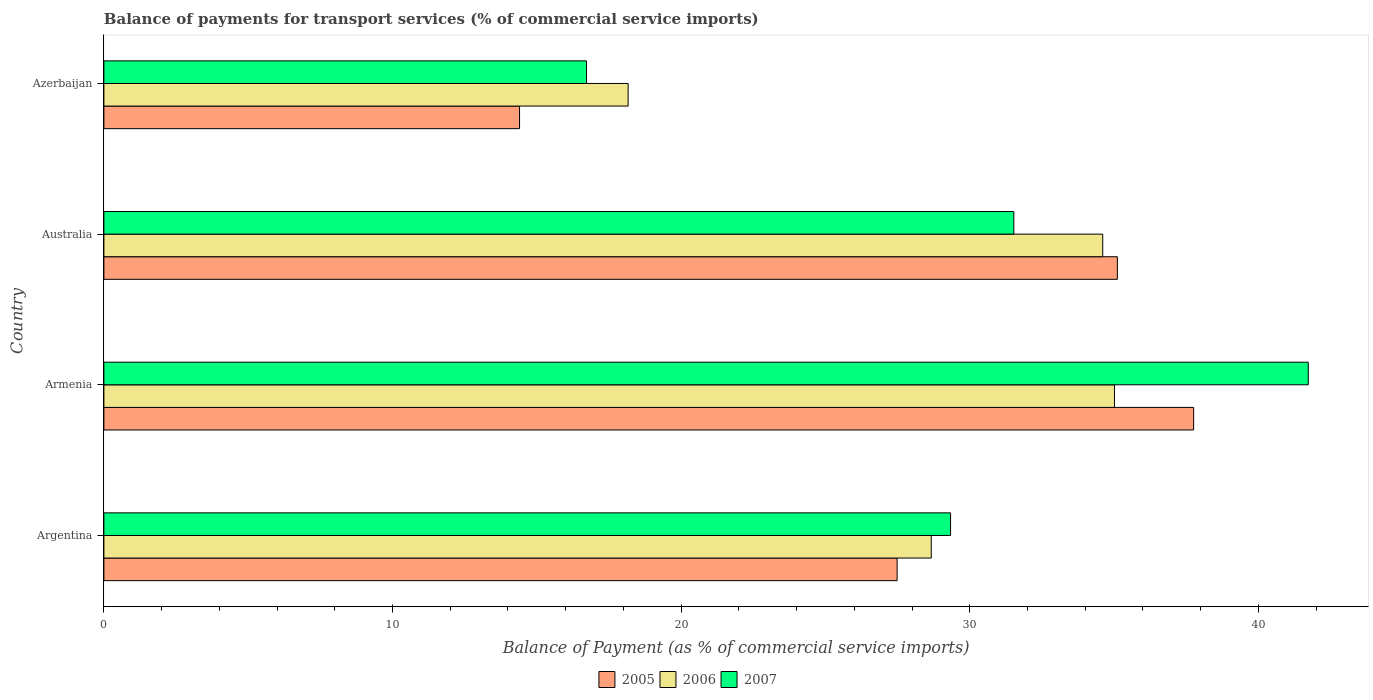How many different coloured bars are there?
Provide a short and direct response. 3. How many groups of bars are there?
Provide a succinct answer. 4. Are the number of bars per tick equal to the number of legend labels?
Give a very brief answer. Yes. How many bars are there on the 2nd tick from the top?
Offer a very short reply. 3. In how many cases, is the number of bars for a given country not equal to the number of legend labels?
Your answer should be compact. 0. What is the balance of payments for transport services in 2007 in Australia?
Your answer should be compact. 31.53. Across all countries, what is the maximum balance of payments for transport services in 2006?
Keep it short and to the point. 35.01. Across all countries, what is the minimum balance of payments for transport services in 2005?
Your response must be concise. 14.4. In which country was the balance of payments for transport services in 2005 maximum?
Provide a short and direct response. Armenia. In which country was the balance of payments for transport services in 2005 minimum?
Keep it short and to the point. Azerbaijan. What is the total balance of payments for transport services in 2007 in the graph?
Provide a succinct answer. 119.31. What is the difference between the balance of payments for transport services in 2007 in Argentina and that in Azerbaijan?
Offer a very short reply. 12.61. What is the difference between the balance of payments for transport services in 2005 in Argentina and the balance of payments for transport services in 2007 in Armenia?
Provide a short and direct response. -14.25. What is the average balance of payments for transport services in 2006 per country?
Give a very brief answer. 29.11. What is the difference between the balance of payments for transport services in 2006 and balance of payments for transport services in 2007 in Australia?
Provide a short and direct response. 3.08. In how many countries, is the balance of payments for transport services in 2006 greater than 26 %?
Ensure brevity in your answer.  3. What is the ratio of the balance of payments for transport services in 2006 in Armenia to that in Azerbaijan?
Your response must be concise. 1.93. Is the balance of payments for transport services in 2007 in Australia less than that in Azerbaijan?
Your answer should be compact. No. Is the difference between the balance of payments for transport services in 2006 in Argentina and Australia greater than the difference between the balance of payments for transport services in 2007 in Argentina and Australia?
Offer a very short reply. No. What is the difference between the highest and the second highest balance of payments for transport services in 2005?
Ensure brevity in your answer.  2.64. What is the difference between the highest and the lowest balance of payments for transport services in 2005?
Your response must be concise. 23.36. In how many countries, is the balance of payments for transport services in 2007 greater than the average balance of payments for transport services in 2007 taken over all countries?
Offer a very short reply. 2. Is it the case that in every country, the sum of the balance of payments for transport services in 2007 and balance of payments for transport services in 2006 is greater than the balance of payments for transport services in 2005?
Your answer should be compact. Yes. What is the difference between two consecutive major ticks on the X-axis?
Your answer should be compact. 10. Are the values on the major ticks of X-axis written in scientific E-notation?
Ensure brevity in your answer.  No. Does the graph contain any zero values?
Keep it short and to the point. No. How many legend labels are there?
Ensure brevity in your answer.  3. How are the legend labels stacked?
Provide a succinct answer. Horizontal. What is the title of the graph?
Ensure brevity in your answer.  Balance of payments for transport services (% of commercial service imports). Does "1976" appear as one of the legend labels in the graph?
Offer a terse response. No. What is the label or title of the X-axis?
Ensure brevity in your answer.  Balance of Payment (as % of commercial service imports). What is the Balance of Payment (as % of commercial service imports) in 2005 in Argentina?
Offer a very short reply. 27.48. What is the Balance of Payment (as % of commercial service imports) in 2006 in Argentina?
Offer a very short reply. 28.67. What is the Balance of Payment (as % of commercial service imports) of 2007 in Argentina?
Make the answer very short. 29.34. What is the Balance of Payment (as % of commercial service imports) in 2005 in Armenia?
Offer a terse response. 37.76. What is the Balance of Payment (as % of commercial service imports) in 2006 in Armenia?
Offer a very short reply. 35.01. What is the Balance of Payment (as % of commercial service imports) in 2007 in Armenia?
Give a very brief answer. 41.73. What is the Balance of Payment (as % of commercial service imports) in 2005 in Australia?
Your answer should be compact. 35.11. What is the Balance of Payment (as % of commercial service imports) in 2006 in Australia?
Offer a very short reply. 34.61. What is the Balance of Payment (as % of commercial service imports) in 2007 in Australia?
Provide a succinct answer. 31.53. What is the Balance of Payment (as % of commercial service imports) in 2005 in Azerbaijan?
Make the answer very short. 14.4. What is the Balance of Payment (as % of commercial service imports) in 2006 in Azerbaijan?
Provide a short and direct response. 18.16. What is the Balance of Payment (as % of commercial service imports) in 2007 in Azerbaijan?
Provide a succinct answer. 16.72. Across all countries, what is the maximum Balance of Payment (as % of commercial service imports) of 2005?
Make the answer very short. 37.76. Across all countries, what is the maximum Balance of Payment (as % of commercial service imports) in 2006?
Provide a short and direct response. 35.01. Across all countries, what is the maximum Balance of Payment (as % of commercial service imports) in 2007?
Offer a very short reply. 41.73. Across all countries, what is the minimum Balance of Payment (as % of commercial service imports) of 2005?
Offer a very short reply. 14.4. Across all countries, what is the minimum Balance of Payment (as % of commercial service imports) in 2006?
Provide a short and direct response. 18.16. Across all countries, what is the minimum Balance of Payment (as % of commercial service imports) of 2007?
Your answer should be compact. 16.72. What is the total Balance of Payment (as % of commercial service imports) of 2005 in the graph?
Make the answer very short. 114.76. What is the total Balance of Payment (as % of commercial service imports) in 2006 in the graph?
Your response must be concise. 116.45. What is the total Balance of Payment (as % of commercial service imports) of 2007 in the graph?
Your response must be concise. 119.31. What is the difference between the Balance of Payment (as % of commercial service imports) in 2005 in Argentina and that in Armenia?
Provide a succinct answer. -10.27. What is the difference between the Balance of Payment (as % of commercial service imports) of 2006 in Argentina and that in Armenia?
Provide a short and direct response. -6.35. What is the difference between the Balance of Payment (as % of commercial service imports) in 2007 in Argentina and that in Armenia?
Provide a short and direct response. -12.39. What is the difference between the Balance of Payment (as % of commercial service imports) of 2005 in Argentina and that in Australia?
Ensure brevity in your answer.  -7.63. What is the difference between the Balance of Payment (as % of commercial service imports) of 2006 in Argentina and that in Australia?
Your answer should be compact. -5.94. What is the difference between the Balance of Payment (as % of commercial service imports) in 2007 in Argentina and that in Australia?
Your answer should be compact. -2.19. What is the difference between the Balance of Payment (as % of commercial service imports) of 2005 in Argentina and that in Azerbaijan?
Make the answer very short. 13.08. What is the difference between the Balance of Payment (as % of commercial service imports) in 2006 in Argentina and that in Azerbaijan?
Your answer should be very brief. 10.5. What is the difference between the Balance of Payment (as % of commercial service imports) of 2007 in Argentina and that in Azerbaijan?
Provide a short and direct response. 12.61. What is the difference between the Balance of Payment (as % of commercial service imports) in 2005 in Armenia and that in Australia?
Your answer should be very brief. 2.64. What is the difference between the Balance of Payment (as % of commercial service imports) in 2006 in Armenia and that in Australia?
Your answer should be compact. 0.41. What is the difference between the Balance of Payment (as % of commercial service imports) in 2007 in Armenia and that in Australia?
Your response must be concise. 10.2. What is the difference between the Balance of Payment (as % of commercial service imports) in 2005 in Armenia and that in Azerbaijan?
Make the answer very short. 23.36. What is the difference between the Balance of Payment (as % of commercial service imports) in 2006 in Armenia and that in Azerbaijan?
Offer a very short reply. 16.85. What is the difference between the Balance of Payment (as % of commercial service imports) in 2007 in Armenia and that in Azerbaijan?
Ensure brevity in your answer.  25.01. What is the difference between the Balance of Payment (as % of commercial service imports) in 2005 in Australia and that in Azerbaijan?
Your response must be concise. 20.71. What is the difference between the Balance of Payment (as % of commercial service imports) in 2006 in Australia and that in Azerbaijan?
Give a very brief answer. 16.44. What is the difference between the Balance of Payment (as % of commercial service imports) in 2007 in Australia and that in Azerbaijan?
Give a very brief answer. 14.81. What is the difference between the Balance of Payment (as % of commercial service imports) of 2005 in Argentina and the Balance of Payment (as % of commercial service imports) of 2006 in Armenia?
Give a very brief answer. -7.53. What is the difference between the Balance of Payment (as % of commercial service imports) of 2005 in Argentina and the Balance of Payment (as % of commercial service imports) of 2007 in Armenia?
Your answer should be very brief. -14.25. What is the difference between the Balance of Payment (as % of commercial service imports) of 2006 in Argentina and the Balance of Payment (as % of commercial service imports) of 2007 in Armenia?
Your response must be concise. -13.06. What is the difference between the Balance of Payment (as % of commercial service imports) of 2005 in Argentina and the Balance of Payment (as % of commercial service imports) of 2006 in Australia?
Keep it short and to the point. -7.12. What is the difference between the Balance of Payment (as % of commercial service imports) of 2005 in Argentina and the Balance of Payment (as % of commercial service imports) of 2007 in Australia?
Give a very brief answer. -4.04. What is the difference between the Balance of Payment (as % of commercial service imports) in 2006 in Argentina and the Balance of Payment (as % of commercial service imports) in 2007 in Australia?
Your answer should be very brief. -2.86. What is the difference between the Balance of Payment (as % of commercial service imports) in 2005 in Argentina and the Balance of Payment (as % of commercial service imports) in 2006 in Azerbaijan?
Offer a terse response. 9.32. What is the difference between the Balance of Payment (as % of commercial service imports) in 2005 in Argentina and the Balance of Payment (as % of commercial service imports) in 2007 in Azerbaijan?
Ensure brevity in your answer.  10.76. What is the difference between the Balance of Payment (as % of commercial service imports) in 2006 in Argentina and the Balance of Payment (as % of commercial service imports) in 2007 in Azerbaijan?
Offer a terse response. 11.95. What is the difference between the Balance of Payment (as % of commercial service imports) in 2005 in Armenia and the Balance of Payment (as % of commercial service imports) in 2006 in Australia?
Offer a very short reply. 3.15. What is the difference between the Balance of Payment (as % of commercial service imports) of 2005 in Armenia and the Balance of Payment (as % of commercial service imports) of 2007 in Australia?
Give a very brief answer. 6.23. What is the difference between the Balance of Payment (as % of commercial service imports) of 2006 in Armenia and the Balance of Payment (as % of commercial service imports) of 2007 in Australia?
Provide a succinct answer. 3.49. What is the difference between the Balance of Payment (as % of commercial service imports) of 2005 in Armenia and the Balance of Payment (as % of commercial service imports) of 2006 in Azerbaijan?
Your answer should be very brief. 19.59. What is the difference between the Balance of Payment (as % of commercial service imports) in 2005 in Armenia and the Balance of Payment (as % of commercial service imports) in 2007 in Azerbaijan?
Ensure brevity in your answer.  21.04. What is the difference between the Balance of Payment (as % of commercial service imports) of 2006 in Armenia and the Balance of Payment (as % of commercial service imports) of 2007 in Azerbaijan?
Offer a terse response. 18.29. What is the difference between the Balance of Payment (as % of commercial service imports) of 2005 in Australia and the Balance of Payment (as % of commercial service imports) of 2006 in Azerbaijan?
Your response must be concise. 16.95. What is the difference between the Balance of Payment (as % of commercial service imports) in 2005 in Australia and the Balance of Payment (as % of commercial service imports) in 2007 in Azerbaijan?
Your answer should be compact. 18.39. What is the difference between the Balance of Payment (as % of commercial service imports) in 2006 in Australia and the Balance of Payment (as % of commercial service imports) in 2007 in Azerbaijan?
Make the answer very short. 17.89. What is the average Balance of Payment (as % of commercial service imports) of 2005 per country?
Make the answer very short. 28.69. What is the average Balance of Payment (as % of commercial service imports) in 2006 per country?
Your answer should be very brief. 29.11. What is the average Balance of Payment (as % of commercial service imports) of 2007 per country?
Your answer should be compact. 29.83. What is the difference between the Balance of Payment (as % of commercial service imports) of 2005 and Balance of Payment (as % of commercial service imports) of 2006 in Argentina?
Your response must be concise. -1.18. What is the difference between the Balance of Payment (as % of commercial service imports) of 2005 and Balance of Payment (as % of commercial service imports) of 2007 in Argentina?
Make the answer very short. -1.85. What is the difference between the Balance of Payment (as % of commercial service imports) of 2006 and Balance of Payment (as % of commercial service imports) of 2007 in Argentina?
Give a very brief answer. -0.67. What is the difference between the Balance of Payment (as % of commercial service imports) of 2005 and Balance of Payment (as % of commercial service imports) of 2006 in Armenia?
Offer a terse response. 2.74. What is the difference between the Balance of Payment (as % of commercial service imports) of 2005 and Balance of Payment (as % of commercial service imports) of 2007 in Armenia?
Offer a terse response. -3.97. What is the difference between the Balance of Payment (as % of commercial service imports) of 2006 and Balance of Payment (as % of commercial service imports) of 2007 in Armenia?
Ensure brevity in your answer.  -6.72. What is the difference between the Balance of Payment (as % of commercial service imports) in 2005 and Balance of Payment (as % of commercial service imports) in 2006 in Australia?
Your answer should be compact. 0.51. What is the difference between the Balance of Payment (as % of commercial service imports) in 2005 and Balance of Payment (as % of commercial service imports) in 2007 in Australia?
Your response must be concise. 3.59. What is the difference between the Balance of Payment (as % of commercial service imports) in 2006 and Balance of Payment (as % of commercial service imports) in 2007 in Australia?
Make the answer very short. 3.08. What is the difference between the Balance of Payment (as % of commercial service imports) in 2005 and Balance of Payment (as % of commercial service imports) in 2006 in Azerbaijan?
Offer a very short reply. -3.76. What is the difference between the Balance of Payment (as % of commercial service imports) in 2005 and Balance of Payment (as % of commercial service imports) in 2007 in Azerbaijan?
Provide a succinct answer. -2.32. What is the difference between the Balance of Payment (as % of commercial service imports) of 2006 and Balance of Payment (as % of commercial service imports) of 2007 in Azerbaijan?
Your response must be concise. 1.44. What is the ratio of the Balance of Payment (as % of commercial service imports) in 2005 in Argentina to that in Armenia?
Offer a terse response. 0.73. What is the ratio of the Balance of Payment (as % of commercial service imports) of 2006 in Argentina to that in Armenia?
Give a very brief answer. 0.82. What is the ratio of the Balance of Payment (as % of commercial service imports) in 2007 in Argentina to that in Armenia?
Keep it short and to the point. 0.7. What is the ratio of the Balance of Payment (as % of commercial service imports) in 2005 in Argentina to that in Australia?
Keep it short and to the point. 0.78. What is the ratio of the Balance of Payment (as % of commercial service imports) of 2006 in Argentina to that in Australia?
Provide a short and direct response. 0.83. What is the ratio of the Balance of Payment (as % of commercial service imports) in 2007 in Argentina to that in Australia?
Give a very brief answer. 0.93. What is the ratio of the Balance of Payment (as % of commercial service imports) of 2005 in Argentina to that in Azerbaijan?
Ensure brevity in your answer.  1.91. What is the ratio of the Balance of Payment (as % of commercial service imports) in 2006 in Argentina to that in Azerbaijan?
Keep it short and to the point. 1.58. What is the ratio of the Balance of Payment (as % of commercial service imports) in 2007 in Argentina to that in Azerbaijan?
Your answer should be very brief. 1.75. What is the ratio of the Balance of Payment (as % of commercial service imports) of 2005 in Armenia to that in Australia?
Make the answer very short. 1.08. What is the ratio of the Balance of Payment (as % of commercial service imports) in 2006 in Armenia to that in Australia?
Offer a very short reply. 1.01. What is the ratio of the Balance of Payment (as % of commercial service imports) of 2007 in Armenia to that in Australia?
Your answer should be compact. 1.32. What is the ratio of the Balance of Payment (as % of commercial service imports) of 2005 in Armenia to that in Azerbaijan?
Your response must be concise. 2.62. What is the ratio of the Balance of Payment (as % of commercial service imports) of 2006 in Armenia to that in Azerbaijan?
Your response must be concise. 1.93. What is the ratio of the Balance of Payment (as % of commercial service imports) of 2007 in Armenia to that in Azerbaijan?
Ensure brevity in your answer.  2.5. What is the ratio of the Balance of Payment (as % of commercial service imports) in 2005 in Australia to that in Azerbaijan?
Make the answer very short. 2.44. What is the ratio of the Balance of Payment (as % of commercial service imports) in 2006 in Australia to that in Azerbaijan?
Offer a terse response. 1.91. What is the ratio of the Balance of Payment (as % of commercial service imports) of 2007 in Australia to that in Azerbaijan?
Give a very brief answer. 1.89. What is the difference between the highest and the second highest Balance of Payment (as % of commercial service imports) of 2005?
Offer a terse response. 2.64. What is the difference between the highest and the second highest Balance of Payment (as % of commercial service imports) in 2006?
Offer a terse response. 0.41. What is the difference between the highest and the second highest Balance of Payment (as % of commercial service imports) in 2007?
Provide a short and direct response. 10.2. What is the difference between the highest and the lowest Balance of Payment (as % of commercial service imports) of 2005?
Your answer should be compact. 23.36. What is the difference between the highest and the lowest Balance of Payment (as % of commercial service imports) in 2006?
Keep it short and to the point. 16.85. What is the difference between the highest and the lowest Balance of Payment (as % of commercial service imports) in 2007?
Provide a succinct answer. 25.01. 